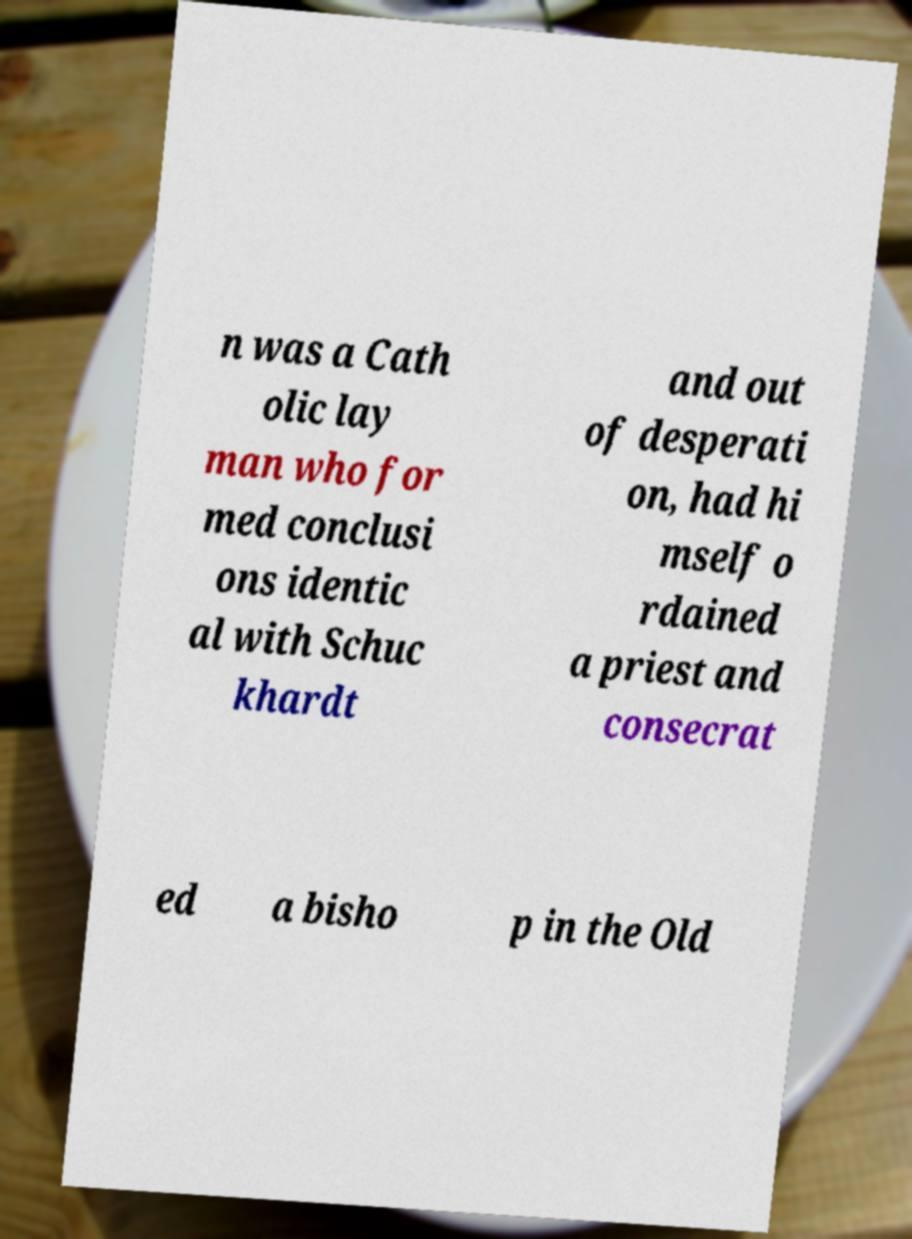Could you assist in decoding the text presented in this image and type it out clearly? n was a Cath olic lay man who for med conclusi ons identic al with Schuc khardt and out of desperati on, had hi mself o rdained a priest and consecrat ed a bisho p in the Old 